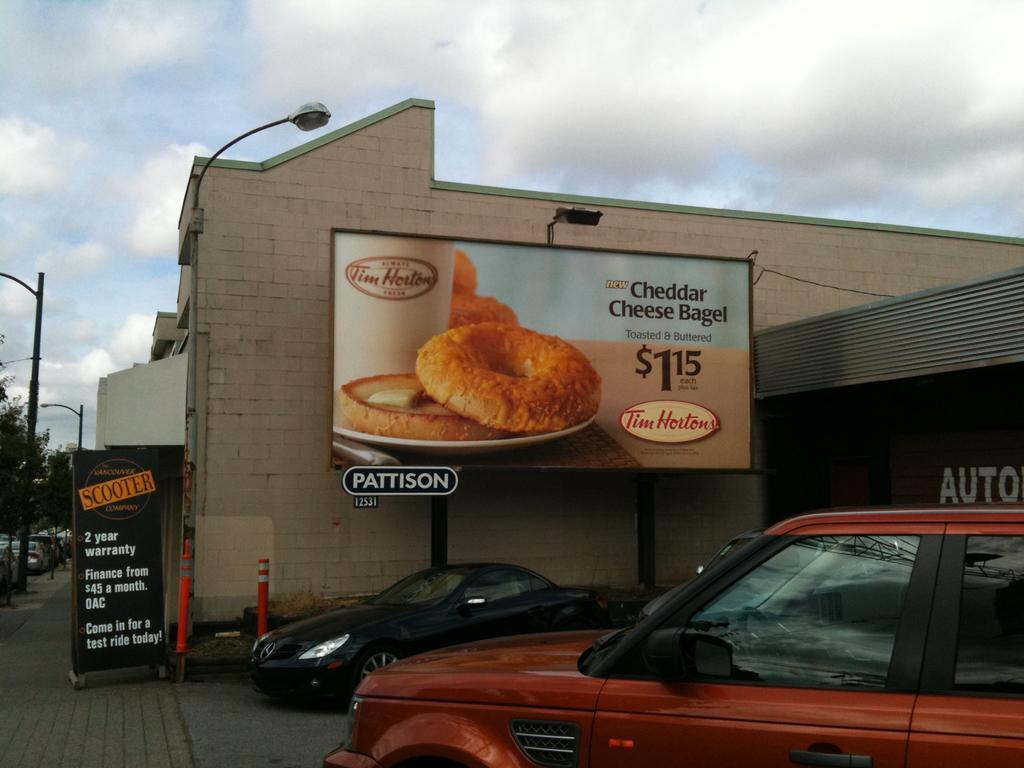Describe this image in one or two sentences. In this picture there are cars at the bottom side of the image and there is a building in the center of the image and there are posters in the image and there are cars, trees, and poles on the left side of the image. 